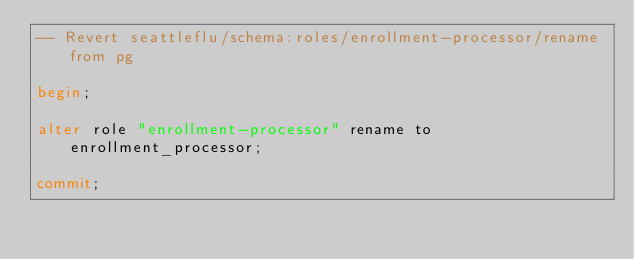<code> <loc_0><loc_0><loc_500><loc_500><_SQL_>-- Revert seattleflu/schema:roles/enrollment-processor/rename from pg

begin;

alter role "enrollment-processor" rename to enrollment_processor;

commit;
</code> 